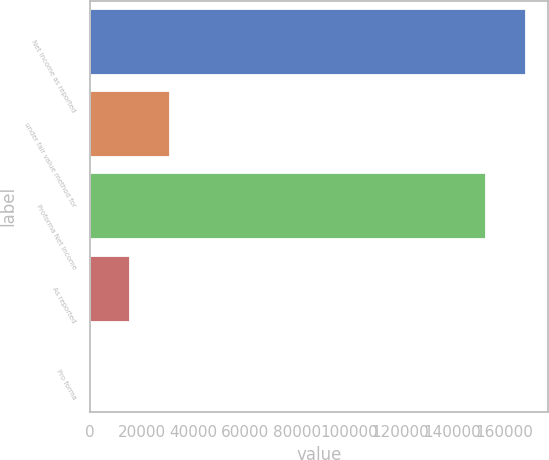Convert chart. <chart><loc_0><loc_0><loc_500><loc_500><bar_chart><fcel>Net income as reported<fcel>under fair value method for<fcel>Proforma Net Income<fcel>As reported<fcel>Pro forma<nl><fcel>168437<fcel>30794.7<fcel>153040<fcel>15397.9<fcel>1.14<nl></chart> 